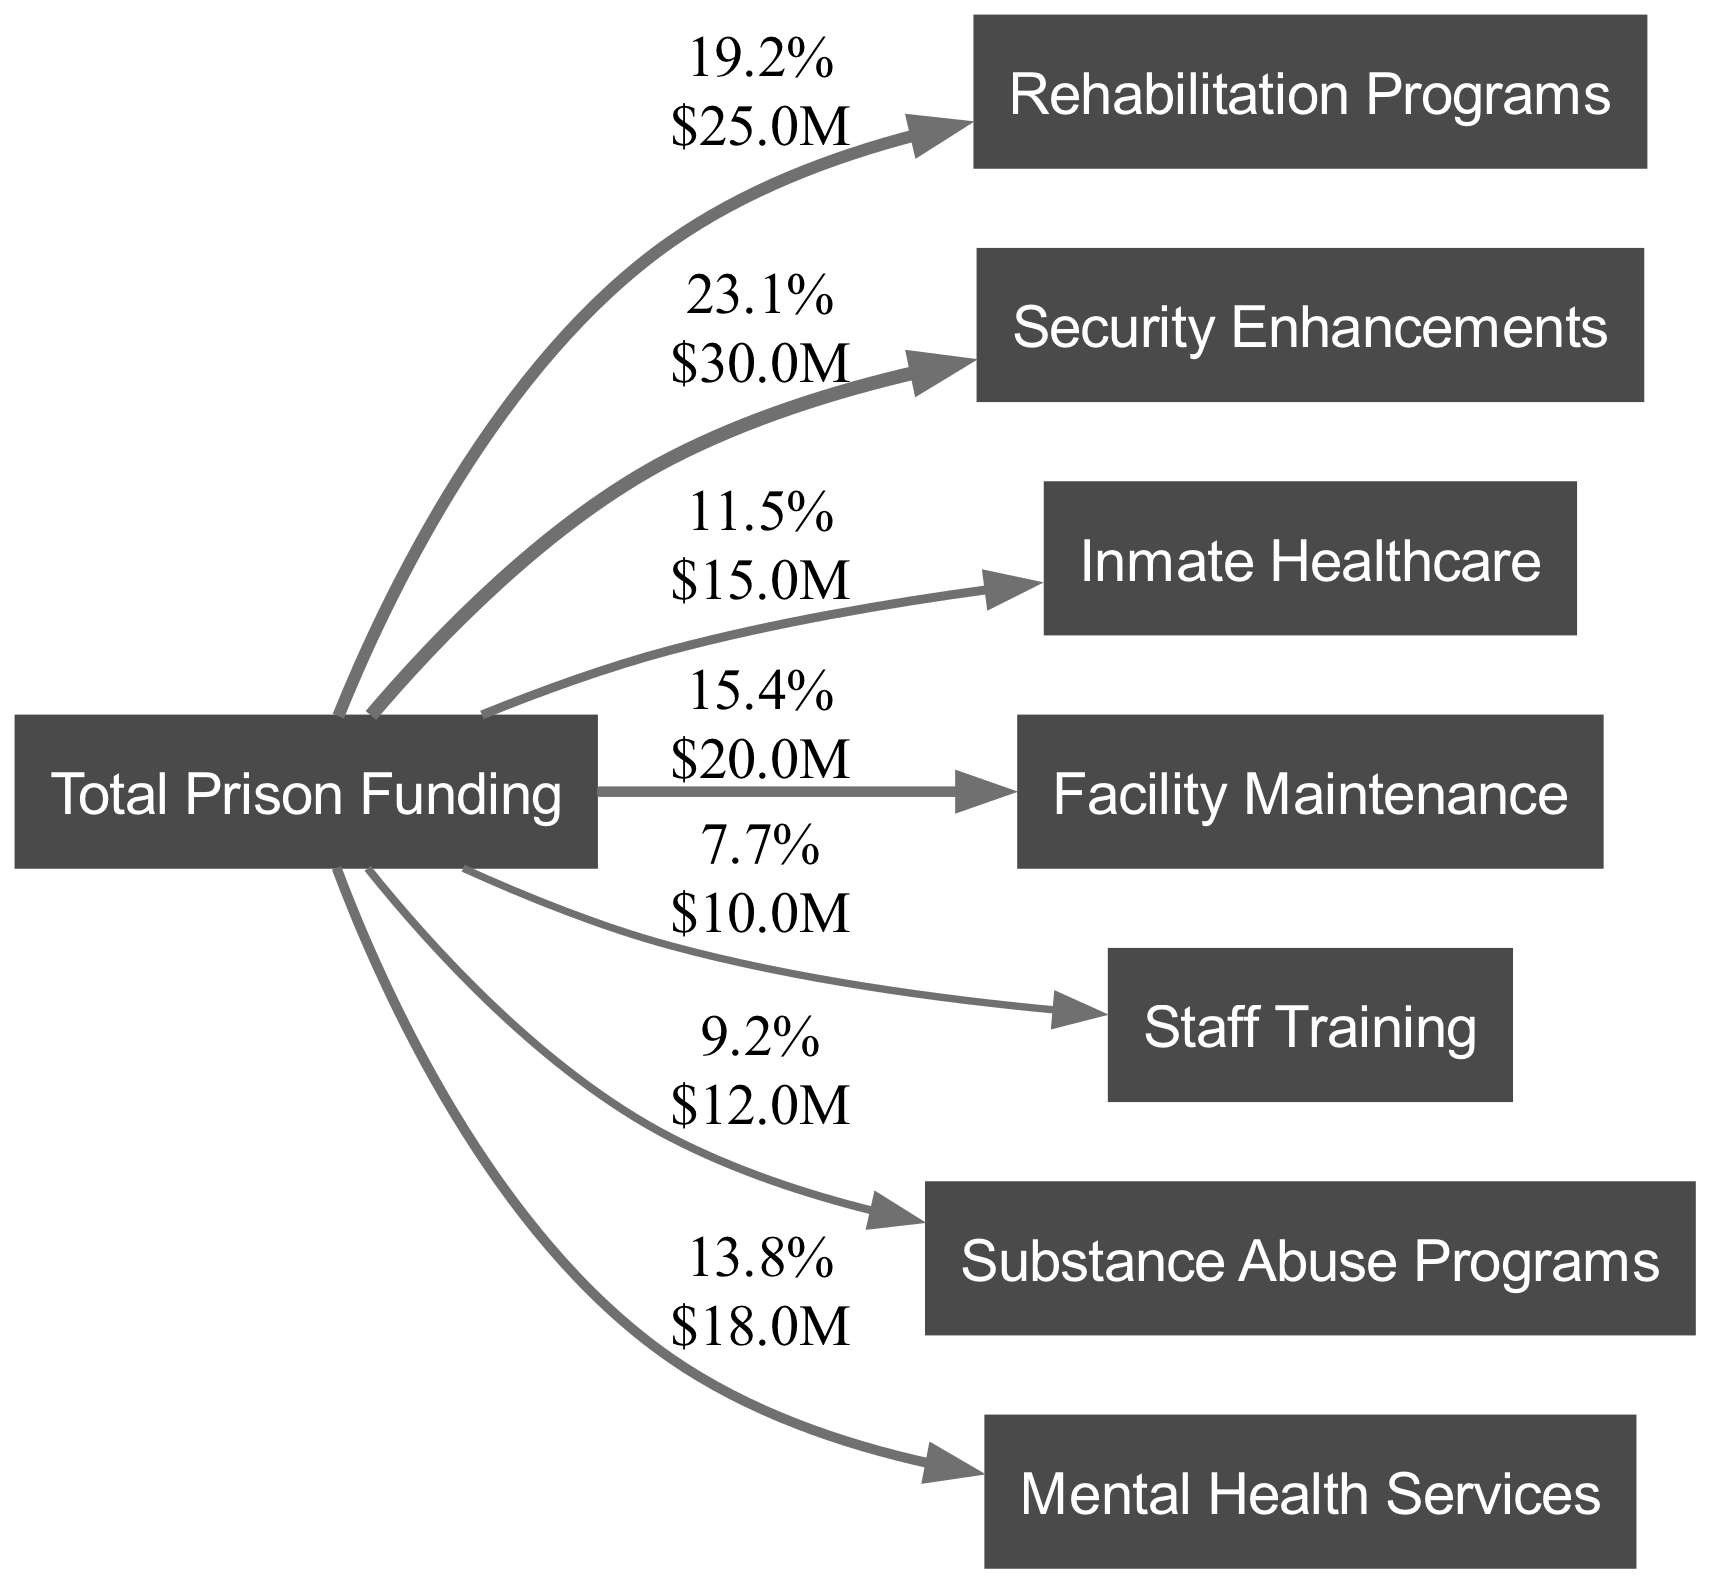What is the total funding amount represented in the diagram? The diagram indicates that total funding is the sum of all the links. By adding all the values from "Rehabilitation Programs", "Security Enhancements", "Inmate Healthcare", "Facility Maintenance", "Staff Training", "Substance Abuse Programs", and "Mental Health Services", we find that the total funding is 100 million dollars.
Answer: 100 million Which area receives the highest funding? Looking at the links from "Total Prison Funding", "Security Enhancements" has the highest value at 30 million. This is the largest allocation among all areas represented in the diagram.
Answer: Security Enhancements How much funding is allocated to staff training? From the diagram, the link to "Staff Training" shows a funding value of 10 million. This is directly specified in the link representing the allocation from the total funding.
Answer: 10 million What is the combined funding for rehabilitation programs and mental health services? To find the combined funding for "Rehabilitation Programs" (25 million) and "Mental Health Services" (18 million), we add these two amounts together: 25 + 18 equals 43 million. This total is derived from both areas' respective values in the diagram.
Answer: 43 million How many areas receive funding from the total prison budget? The diagram lists eight distinct areas as nodes linked from "Total Prison Funding". By counting all the nodes linked from the total funding node, we confirm there are eight areas.
Answer: 8 Which program has the least amount of funding allocated? Checking the values in the links, "Staff Training" has the least funding of 10 million. This is clearly indicated as the smallest value among the links.
Answer: Staff Training What percentage of the total funding is allocated to inmate healthcare? The funding for "Inmate Healthcare" is 15 million. Calculating the percentage involves dividing this amount by the total funding (100 million) and then multiplying by 100, which gives us 15%. Hence, the allocated percentage for inmate healthcare is clearly shown in the diagram.
Answer: 15% How does the funding for substance abuse programs compare to that for mental health services? "Substance Abuse Programs" has funding of 12 million, while "Mental Health Services" has 18 million. Comparing these values shows that mental health services have 6 million more than substance abuse programs, and this can be deduced by looking at the respective links in the diagram.
Answer: 6 million more 